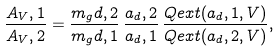<formula> <loc_0><loc_0><loc_500><loc_500>\frac { A _ { V } , 1 } { A _ { V } , 2 } = \frac { m _ { g } d , 2 } { m _ { g } d , 1 } \, \frac { a _ { d } , 2 } { a _ { d } , 1 } \, \frac { Q e x t ( a _ { d } , 1 , V ) } { Q e x t ( a _ { d } , 2 , V ) } ,</formula> 